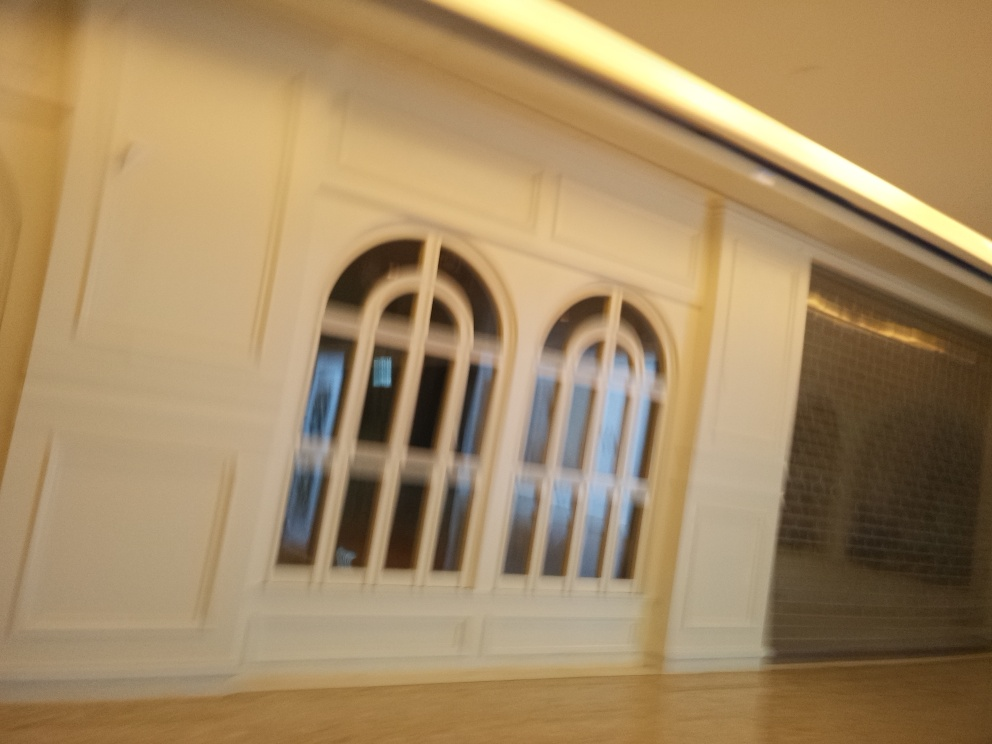Is there blurriness present in the image?
A. No
B. Yes
Answer with the option's letter from the given choices directly.
 B. 